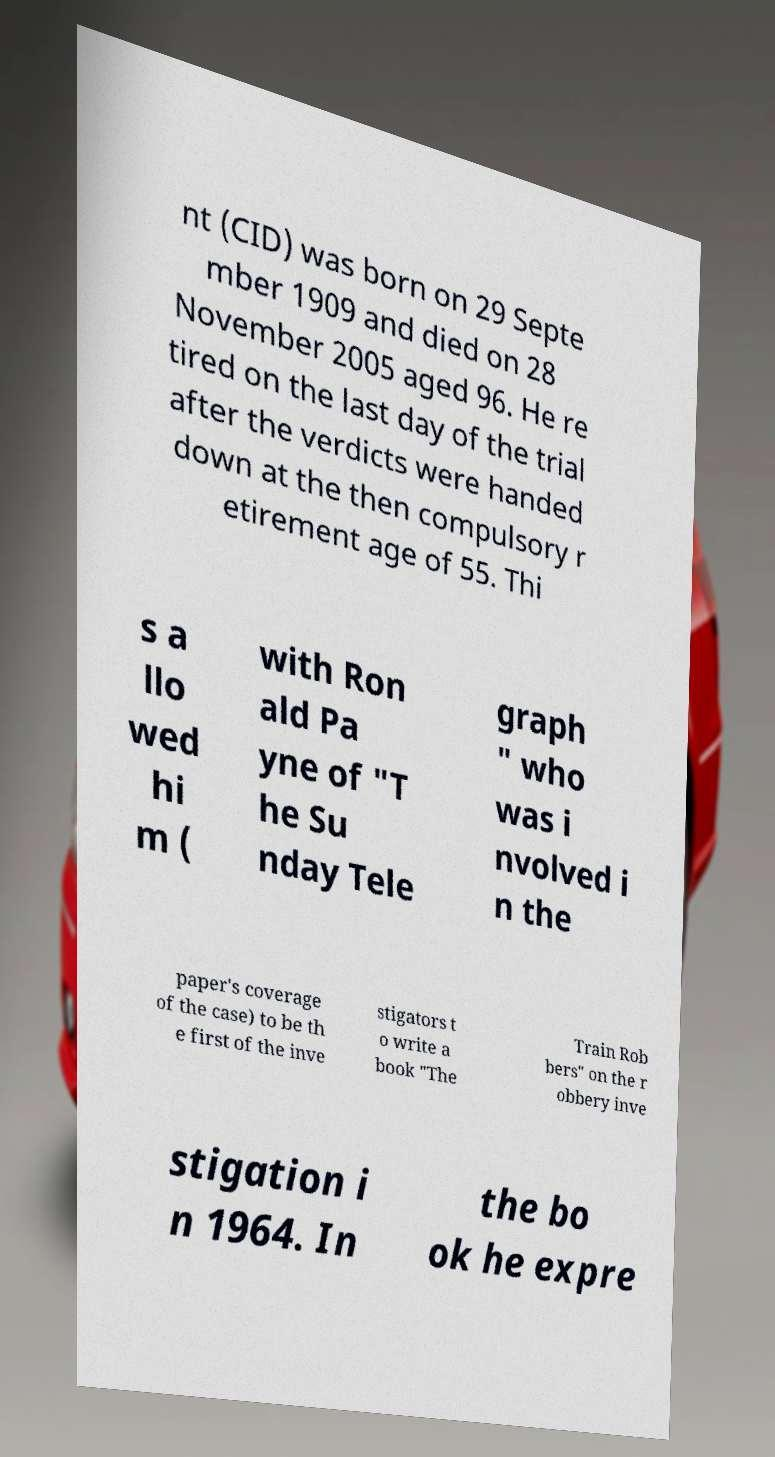Can you read and provide the text displayed in the image?This photo seems to have some interesting text. Can you extract and type it out for me? nt (CID) was born on 29 Septe mber 1909 and died on 28 November 2005 aged 96. He re tired on the last day of the trial after the verdicts were handed down at the then compulsory r etirement age of 55. Thi s a llo wed hi m ( with Ron ald Pa yne of "T he Su nday Tele graph " who was i nvolved i n the paper's coverage of the case) to be th e first of the inve stigators t o write a book "The Train Rob bers" on the r obbery inve stigation i n 1964. In the bo ok he expre 